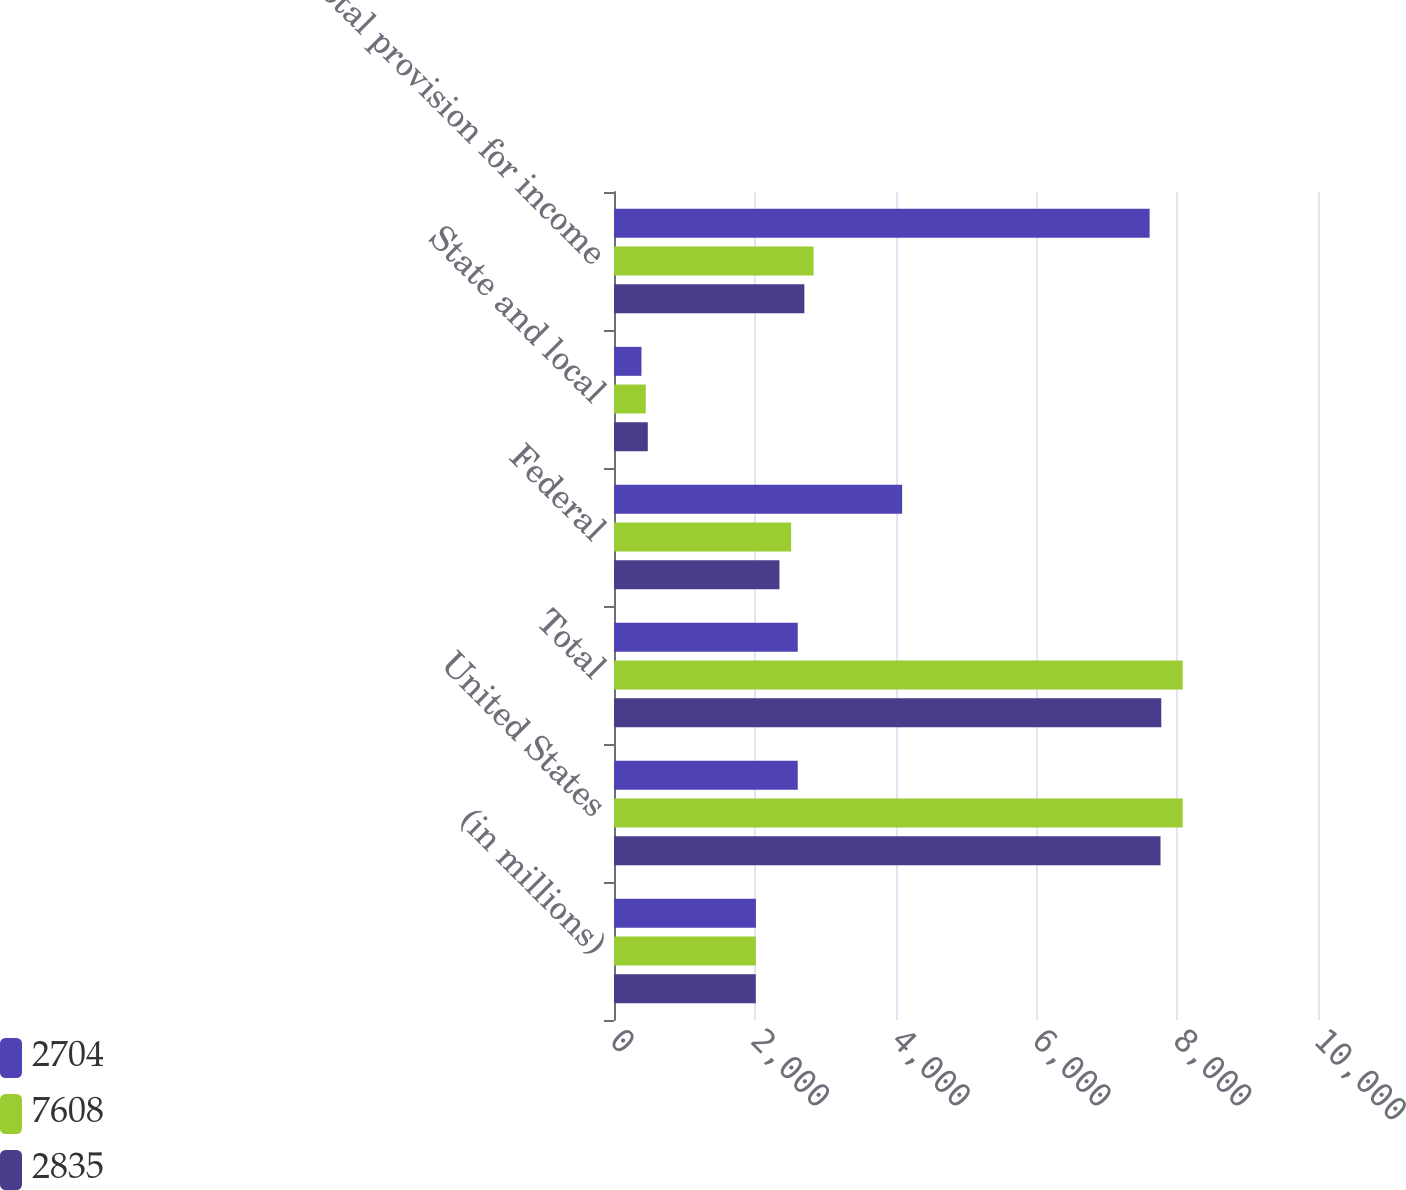<chart> <loc_0><loc_0><loc_500><loc_500><stacked_bar_chart><ecel><fcel>(in millions)<fcel>United States<fcel>Total<fcel>Federal<fcel>State and local<fcel>Total provision for income<nl><fcel>2704<fcel>2016<fcel>2610<fcel>2610<fcel>4093<fcel>390<fcel>7608<nl><fcel>7608<fcel>2015<fcel>8078<fcel>8078<fcel>2516<fcel>451<fcel>2835<nl><fcel>2835<fcel>2014<fcel>7763<fcel>7774<fcel>2350<fcel>480<fcel>2704<nl></chart> 